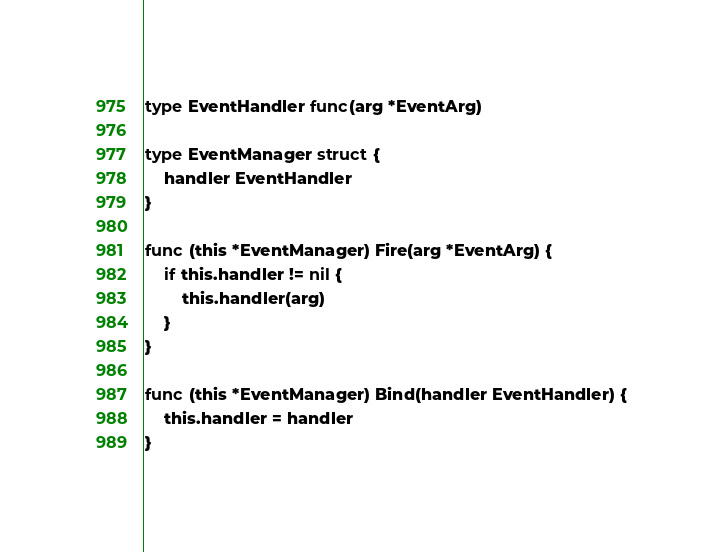Convert code to text. <code><loc_0><loc_0><loc_500><loc_500><_Go_>
type EventHandler func(arg *EventArg)

type EventManager struct {
    handler EventHandler
}

func (this *EventManager) Fire(arg *EventArg) {
    if this.handler != nil {
        this.handler(arg)
    }
}

func (this *EventManager) Bind(handler EventHandler) {
    this.handler = handler
}
</code> 